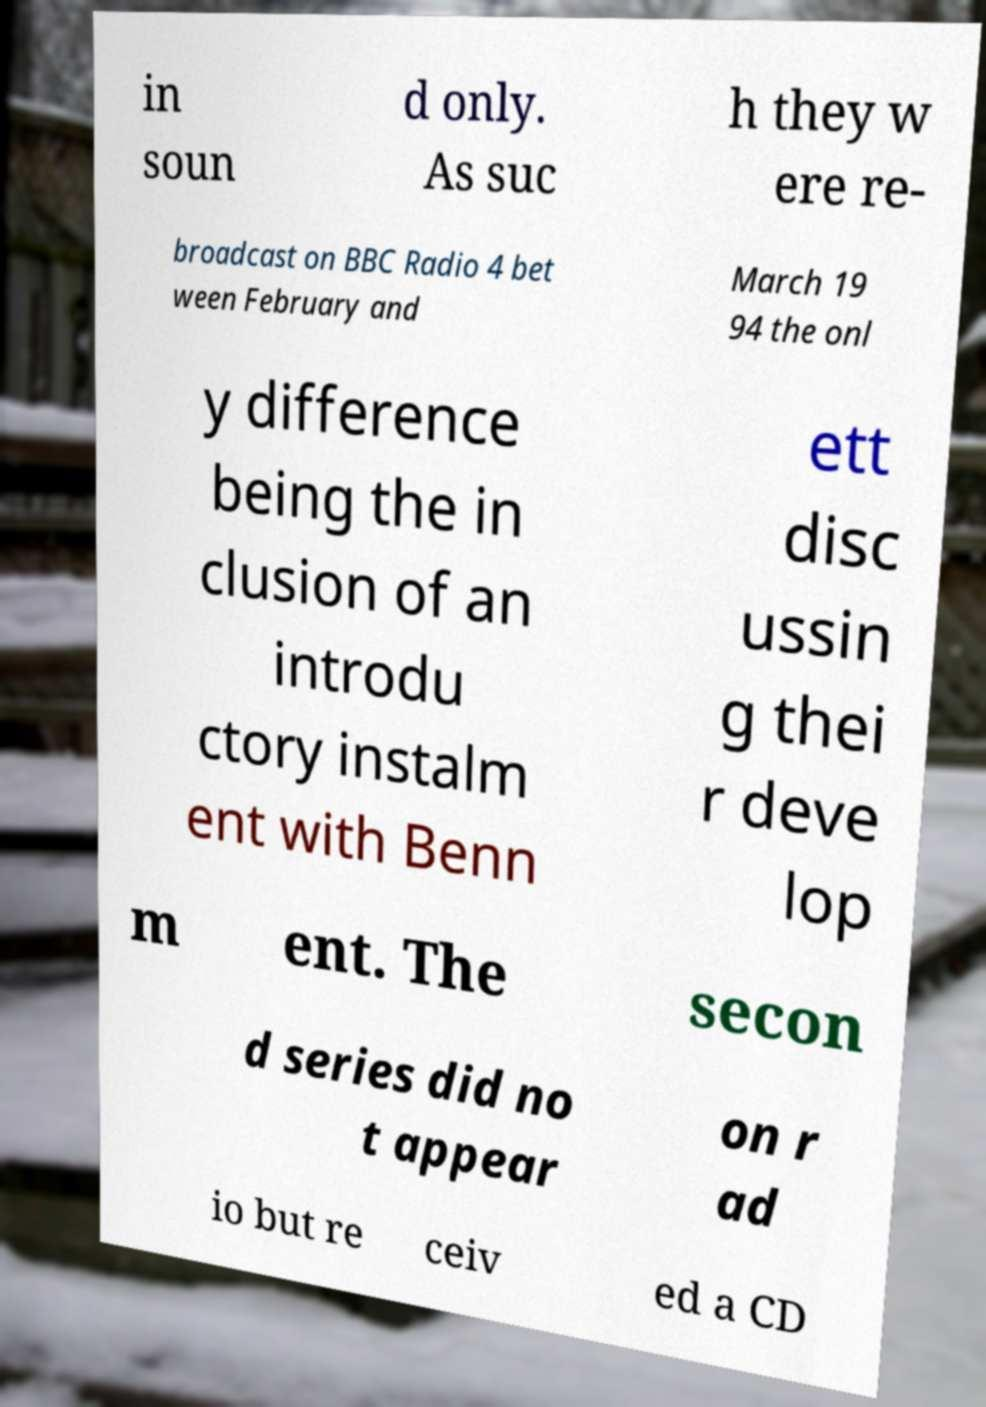Can you accurately transcribe the text from the provided image for me? in soun d only. As suc h they w ere re- broadcast on BBC Radio 4 bet ween February and March 19 94 the onl y difference being the in clusion of an introdu ctory instalm ent with Benn ett disc ussin g thei r deve lop m ent. The secon d series did no t appear on r ad io but re ceiv ed a CD 